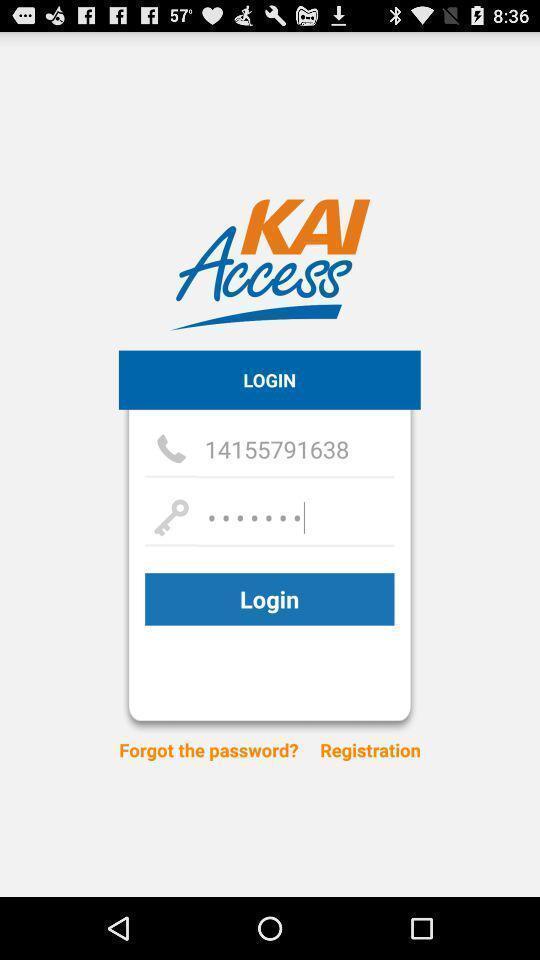Provide a description of this screenshot. Welcome page asking for login details. 